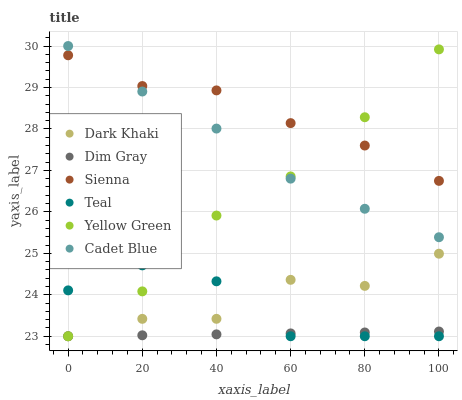Does Dim Gray have the minimum area under the curve?
Answer yes or no. Yes. Does Sienna have the maximum area under the curve?
Answer yes or no. Yes. Does Yellow Green have the minimum area under the curve?
Answer yes or no. No. Does Yellow Green have the maximum area under the curve?
Answer yes or no. No. Is Dim Gray the smoothest?
Answer yes or no. Yes. Is Dark Khaki the roughest?
Answer yes or no. Yes. Is Yellow Green the smoothest?
Answer yes or no. No. Is Yellow Green the roughest?
Answer yes or no. No. Does Dim Gray have the lowest value?
Answer yes or no. Yes. Does Cadet Blue have the lowest value?
Answer yes or no. No. Does Cadet Blue have the highest value?
Answer yes or no. Yes. Does Yellow Green have the highest value?
Answer yes or no. No. Is Dim Gray less than Cadet Blue?
Answer yes or no. Yes. Is Sienna greater than Dark Khaki?
Answer yes or no. Yes. Does Yellow Green intersect Teal?
Answer yes or no. Yes. Is Yellow Green less than Teal?
Answer yes or no. No. Is Yellow Green greater than Teal?
Answer yes or no. No. Does Dim Gray intersect Cadet Blue?
Answer yes or no. No. 